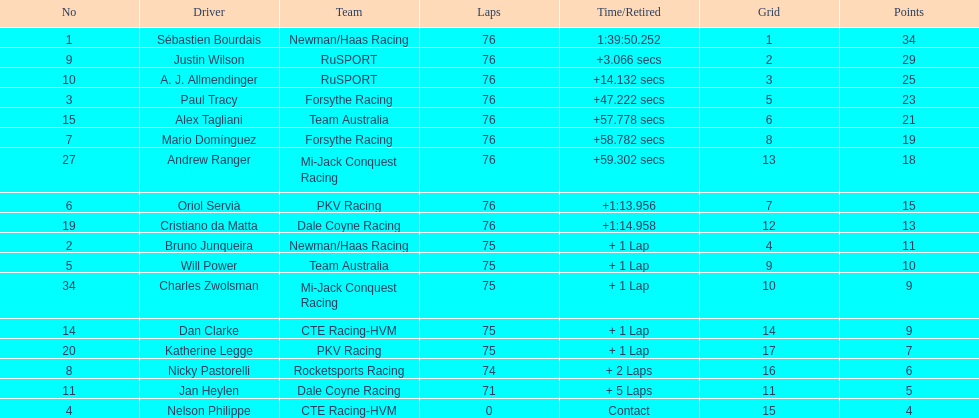Which driver possesses the minimum number of points? Nelson Philippe. 